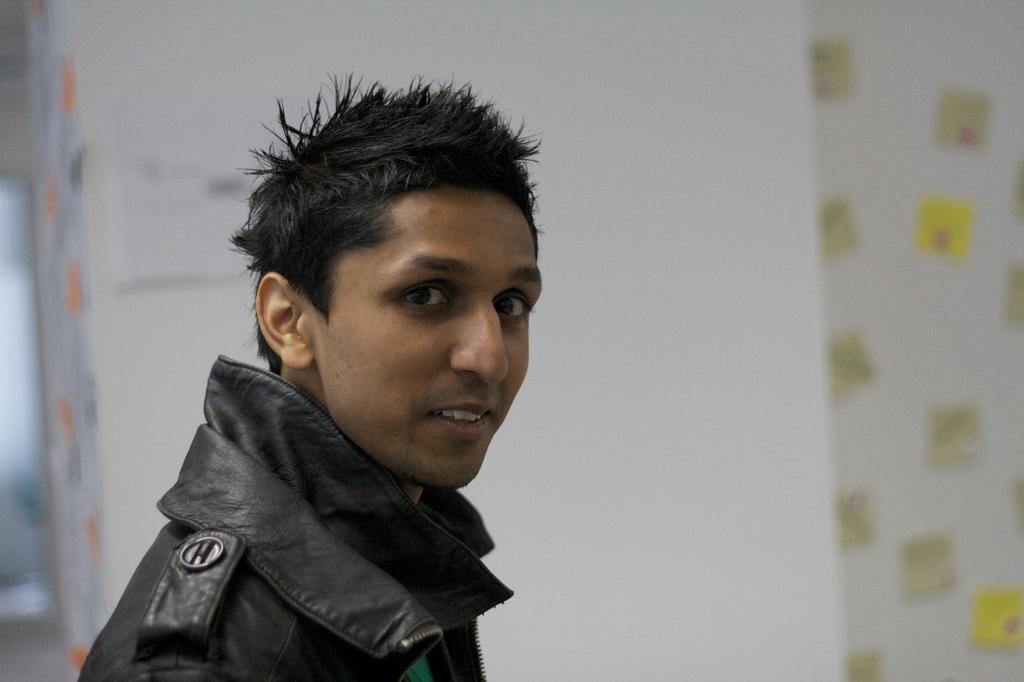In one or two sentences, can you explain what this image depicts? In this image there is one person wearing a black color jacket on the left side of this image and there is a white color wall in the background. 